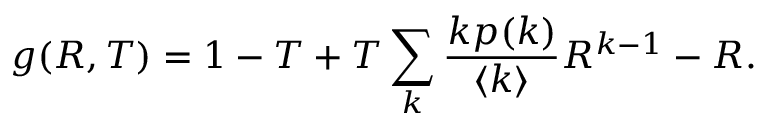Convert formula to latex. <formula><loc_0><loc_0><loc_500><loc_500>g ( R , T ) = 1 - T + T \sum _ { k } \frac { k p ( k ) } { \langle k \rangle } R ^ { k - 1 } - R .</formula> 